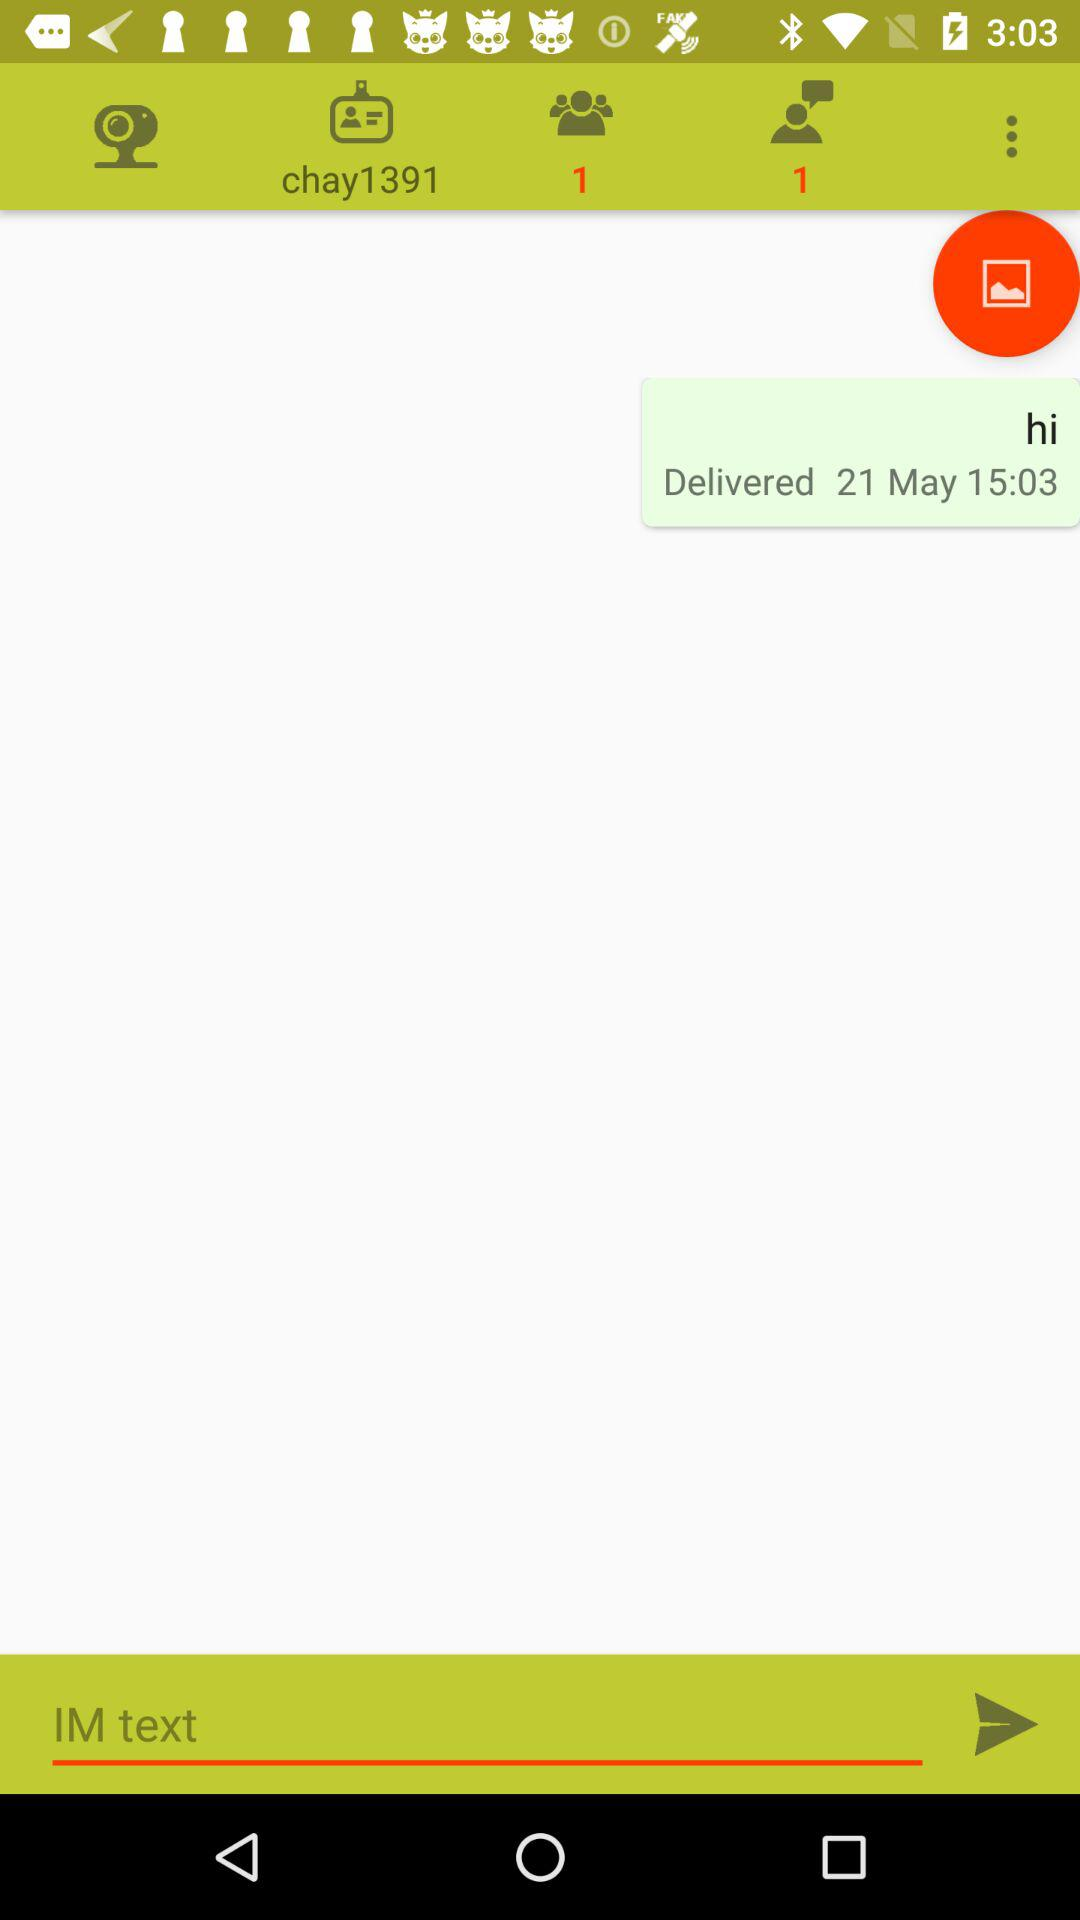When was the message delivered? The message was delivered on May 21 at 15:03. 